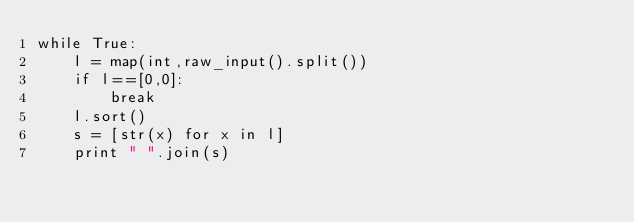<code> <loc_0><loc_0><loc_500><loc_500><_Python_>while True:
    l = map(int,raw_input().split())
    if l==[0,0]:
        break
    l.sort()
    s = [str(x) for x in l]
    print " ".join(s)</code> 